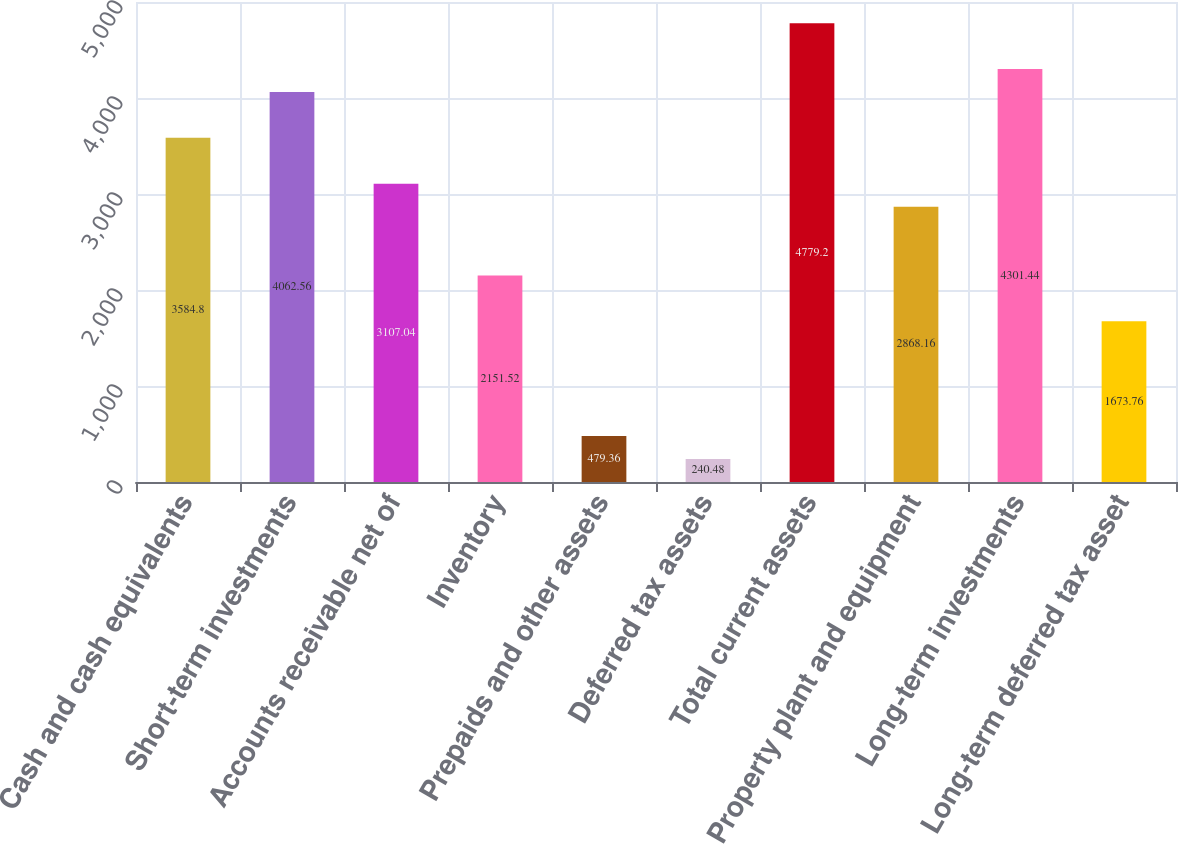Convert chart to OTSL. <chart><loc_0><loc_0><loc_500><loc_500><bar_chart><fcel>Cash and cash equivalents<fcel>Short-term investments<fcel>Accounts receivable net of<fcel>Inventory<fcel>Prepaids and other assets<fcel>Deferred tax assets<fcel>Total current assets<fcel>Property plant and equipment<fcel>Long-term investments<fcel>Long-term deferred tax asset<nl><fcel>3584.8<fcel>4062.56<fcel>3107.04<fcel>2151.52<fcel>479.36<fcel>240.48<fcel>4779.2<fcel>2868.16<fcel>4301.44<fcel>1673.76<nl></chart> 